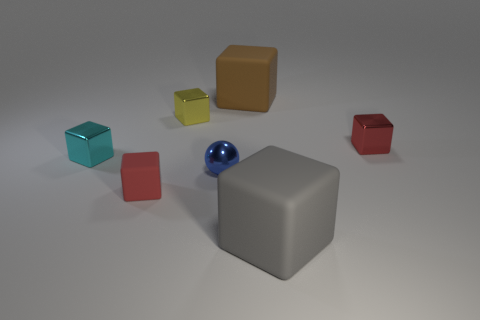What is the color of the other small matte object that is the same shape as the yellow thing?
Give a very brief answer. Red. There is a tiny rubber block; is it the same color as the block to the right of the gray cube?
Ensure brevity in your answer.  Yes. What shape is the matte object that is both to the right of the blue shiny thing and behind the big gray thing?
Your answer should be very brief. Cube. Are there fewer small red metal cubes than small green cylinders?
Offer a terse response. No. Are there any big gray shiny cylinders?
Make the answer very short. No. What number of other objects are there of the same size as the red matte object?
Offer a very short reply. 4. Do the tiny blue ball and the big cube that is in front of the tiny yellow block have the same material?
Provide a short and direct response. No. Are there an equal number of big brown objects to the left of the brown cube and rubber objects that are behind the small red matte object?
Your answer should be very brief. No. What is the material of the yellow cube?
Your response must be concise. Metal. The matte cube that is the same size as the blue metallic sphere is what color?
Provide a succinct answer. Red. 